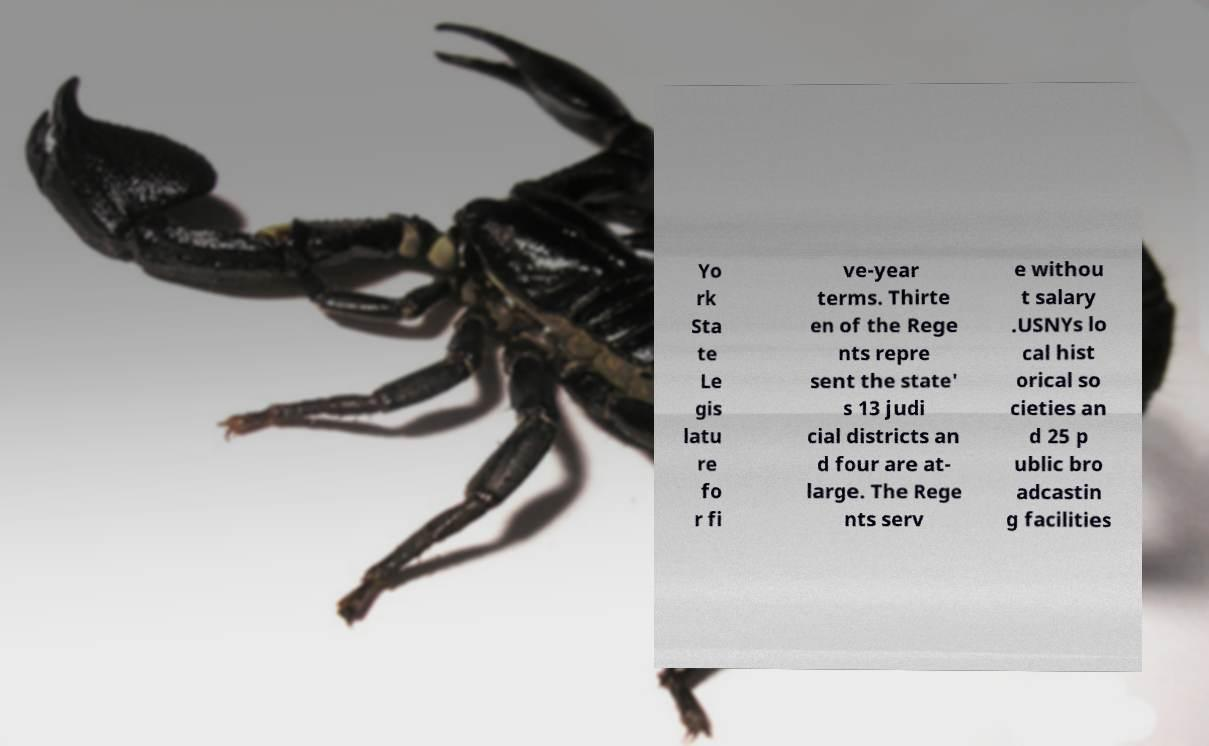Can you read and provide the text displayed in the image?This photo seems to have some interesting text. Can you extract and type it out for me? Yo rk Sta te Le gis latu re fo r fi ve-year terms. Thirte en of the Rege nts repre sent the state' s 13 judi cial districts an d four are at- large. The Rege nts serv e withou t salary .USNYs lo cal hist orical so cieties an d 25 p ublic bro adcastin g facilities 